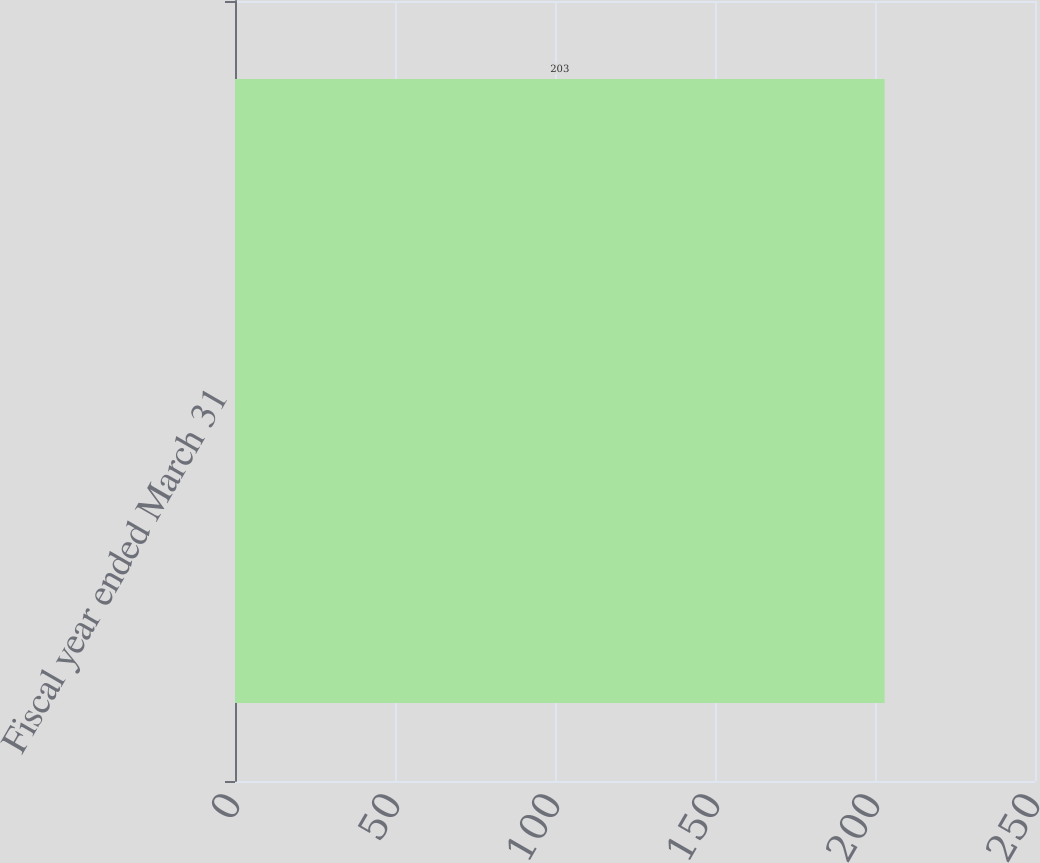Convert chart to OTSL. <chart><loc_0><loc_0><loc_500><loc_500><bar_chart><fcel>Fiscal year ended March 31<nl><fcel>203<nl></chart> 